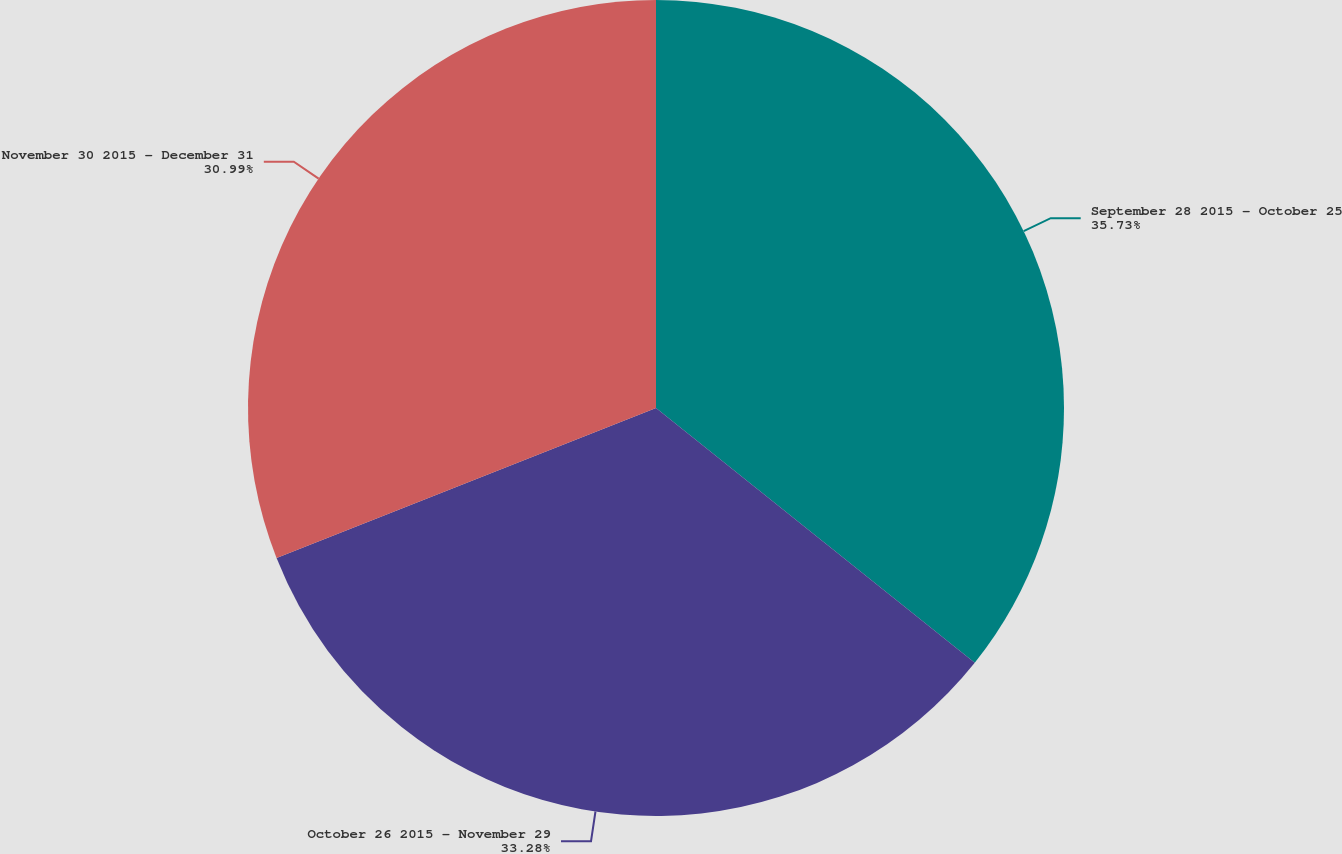<chart> <loc_0><loc_0><loc_500><loc_500><pie_chart><fcel>September 28 2015 - October 25<fcel>October 26 2015 - November 29<fcel>November 30 2015 - December 31<nl><fcel>35.73%<fcel>33.28%<fcel>30.99%<nl></chart> 